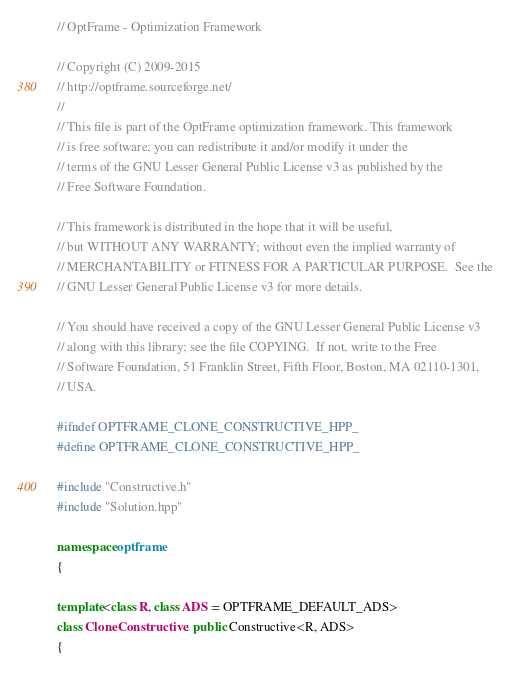Convert code to text. <code><loc_0><loc_0><loc_500><loc_500><_C++_>// OptFrame - Optimization Framework

// Copyright (C) 2009-2015
// http://optframe.sourceforge.net/
//
// This file is part of the OptFrame optimization framework. This framework
// is free software; you can redistribute it and/or modify it under the
// terms of the GNU Lesser General Public License v3 as published by the
// Free Software Foundation.

// This framework is distributed in the hope that it will be useful,
// but WITHOUT ANY WARRANTY; without even the implied warranty of
// MERCHANTABILITY or FITNESS FOR A PARTICULAR PURPOSE.  See the
// GNU Lesser General Public License v3 for more details.

// You should have received a copy of the GNU Lesser General Public License v3
// along with this library; see the file COPYING.  If not, write to the Free
// Software Foundation, 51 Franklin Street, Fifth Floor, Boston, MA 02110-1301,
// USA.

#ifndef OPTFRAME_CLONE_CONSTRUCTIVE_HPP_
#define OPTFRAME_CLONE_CONSTRUCTIVE_HPP_

#include "Constructive.h"
#include "Solution.hpp"

namespace optframe
{

template<class R, class ADS = OPTFRAME_DEFAULT_ADS>
class CloneConstructive : public Constructive<R, ADS>
{</code> 